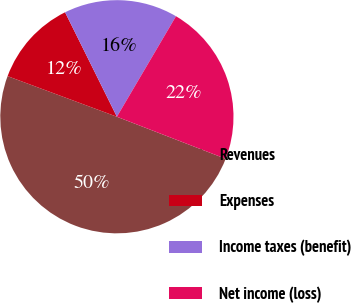Convert chart. <chart><loc_0><loc_0><loc_500><loc_500><pie_chart><fcel>Revenues<fcel>Expenses<fcel>Income taxes (benefit)<fcel>Net income (loss)<nl><fcel>49.79%<fcel>12.01%<fcel>15.79%<fcel>22.41%<nl></chart> 